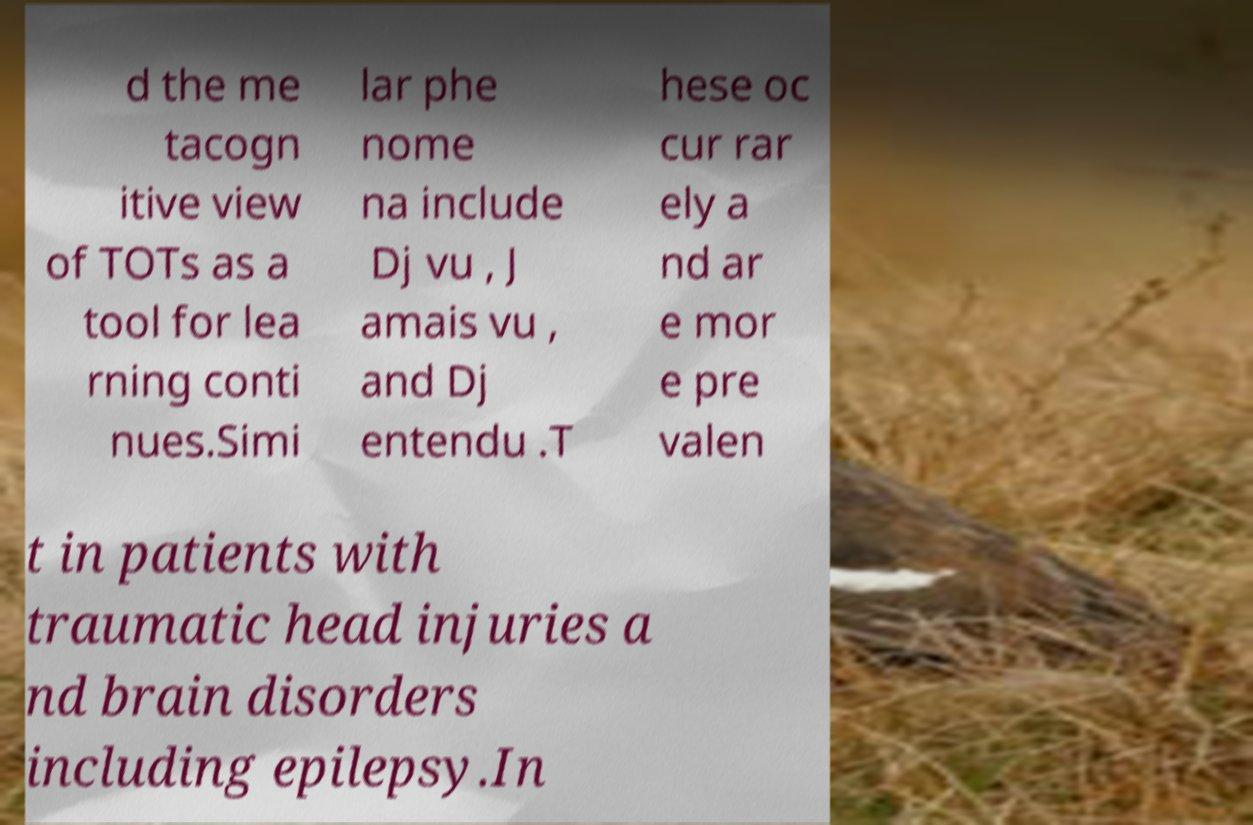Can you read and provide the text displayed in the image?This photo seems to have some interesting text. Can you extract and type it out for me? d the me tacogn itive view of TOTs as a tool for lea rning conti nues.Simi lar phe nome na include Dj vu , J amais vu , and Dj entendu .T hese oc cur rar ely a nd ar e mor e pre valen t in patients with traumatic head injuries a nd brain disorders including epilepsy.In 